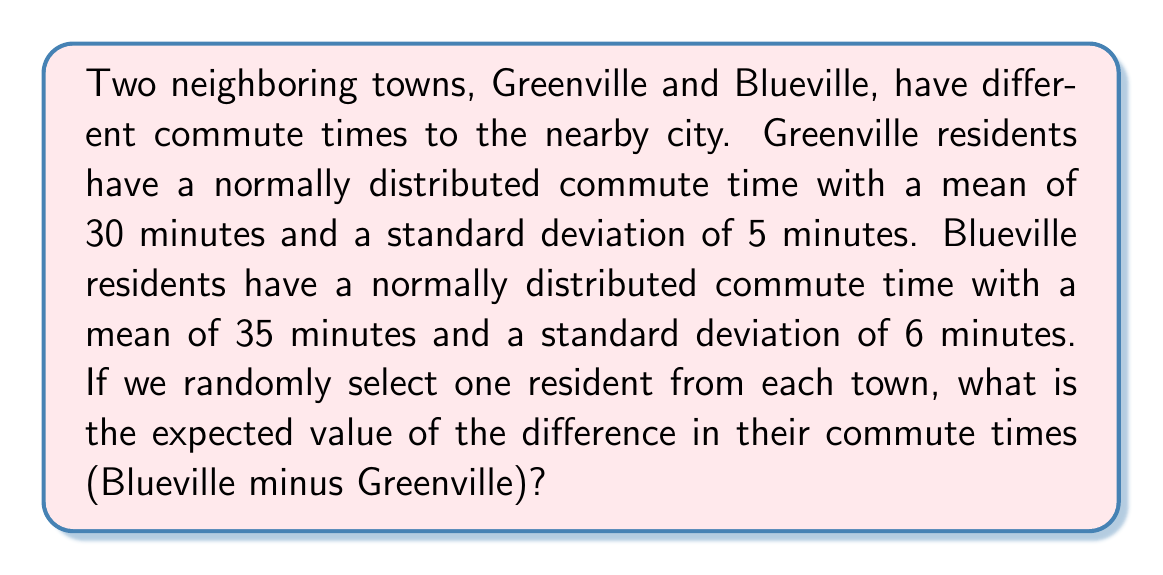Can you solve this math problem? Let's approach this step-by-step:

1) Let $X$ be the commute time for a Greenville resident and $Y$ be the commute time for a Blueville resident.

2) We're given:
   $X \sim N(\mu_X = 30, \sigma_X = 5)$
   $Y \sim N(\mu_Y = 35, \sigma_Y = 6)$

3) We're interested in the difference $Z = Y - X$

4) For the difference of two normal random variables:
   $E[Y - X] = E[Y] - E[X]$

5) We know the expected values (means) for both X and Y:
   $E[X] = 30$
   $E[Y] = 35$

6) Therefore:
   $E[Z] = E[Y - X] = E[Y] - E[X] = 35 - 30 = 5$

This means that, on average, we expect a Blueville resident's commute time to be 5 minutes longer than a Greenville resident's commute time.

Note: While we didn't need to use the standard deviations for this calculation, they would be relevant if we were asked about the variance or probability of certain differences.
Answer: The expected value of the difference in commute times (Blueville minus Greenville) is 5 minutes. 